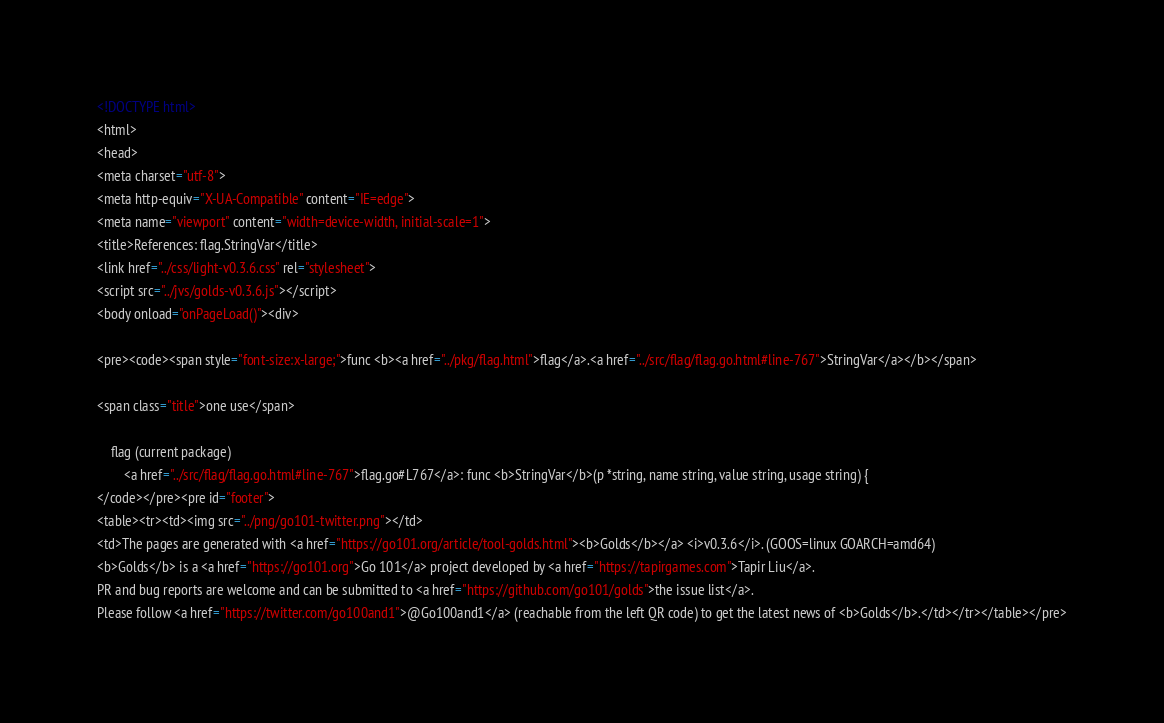<code> <loc_0><loc_0><loc_500><loc_500><_HTML_><!DOCTYPE html>
<html>
<head>
<meta charset="utf-8">
<meta http-equiv="X-UA-Compatible" content="IE=edge">
<meta name="viewport" content="width=device-width, initial-scale=1">
<title>References: flag.StringVar</title>
<link href="../css/light-v0.3.6.css" rel="stylesheet">
<script src="../jvs/golds-v0.3.6.js"></script>
<body onload="onPageLoad()"><div>

<pre><code><span style="font-size:x-large;">func <b><a href="../pkg/flag.html">flag</a>.<a href="../src/flag/flag.go.html#line-767">StringVar</a></b></span>

<span class="title">one use</span>

	flag (current package)
		<a href="../src/flag/flag.go.html#line-767">flag.go#L767</a>: func <b>StringVar</b>(p *string, name string, value string, usage string) {
</code></pre><pre id="footer">
<table><tr><td><img src="../png/go101-twitter.png"></td>
<td>The pages are generated with <a href="https://go101.org/article/tool-golds.html"><b>Golds</b></a> <i>v0.3.6</i>. (GOOS=linux GOARCH=amd64)
<b>Golds</b> is a <a href="https://go101.org">Go 101</a> project developed by <a href="https://tapirgames.com">Tapir Liu</a>.
PR and bug reports are welcome and can be submitted to <a href="https://github.com/go101/golds">the issue list</a>.
Please follow <a href="https://twitter.com/go100and1">@Go100and1</a> (reachable from the left QR code) to get the latest news of <b>Golds</b>.</td></tr></table></pre></code> 